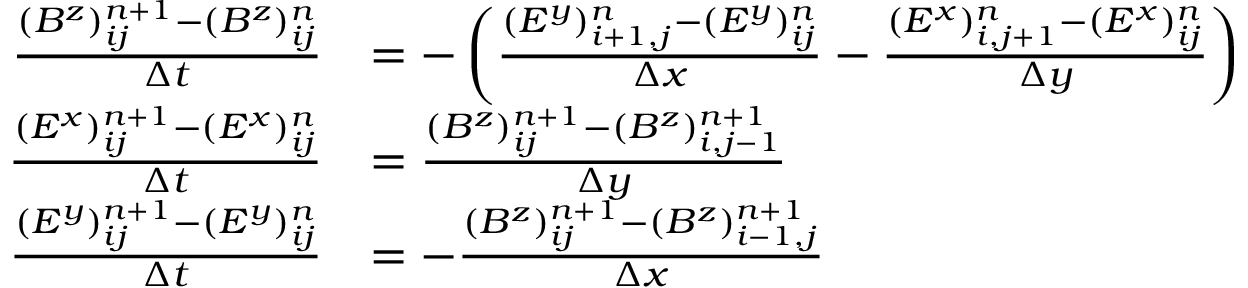<formula> <loc_0><loc_0><loc_500><loc_500>\begin{array} { r l } { \frac { ( B ^ { z } ) _ { i j } ^ { n + 1 } - ( B ^ { z } ) _ { i j } ^ { n } } { \Delta t } } & { = - \left ( \frac { ( E ^ { y } ) _ { i + 1 , j } ^ { n } - ( E ^ { y } ) _ { i j } ^ { n } } { \Delta x } - \frac { ( E ^ { x } ) _ { i , j + 1 } ^ { n } - ( E ^ { x } ) _ { i j } ^ { n } } { \Delta y } \right ) } \\ { \frac { ( E ^ { x } ) _ { i j } ^ { n + 1 } - ( E ^ { x } ) _ { i j } ^ { n } } { \Delta t } } & { = \frac { ( B ^ { z } ) _ { i j } ^ { n + 1 } - ( B ^ { z } ) _ { i , j - 1 } ^ { n + 1 } } { \Delta y } } \\ { \frac { ( E ^ { y } ) _ { i j } ^ { n + 1 } - ( E ^ { y } ) _ { i j } ^ { n } } { \Delta t } } & { = - \frac { ( B ^ { z } ) _ { i j } ^ { n + 1 } - ( B ^ { z } ) _ { i - 1 , j } ^ { n + 1 } } { \Delta x } } \end{array}</formula> 